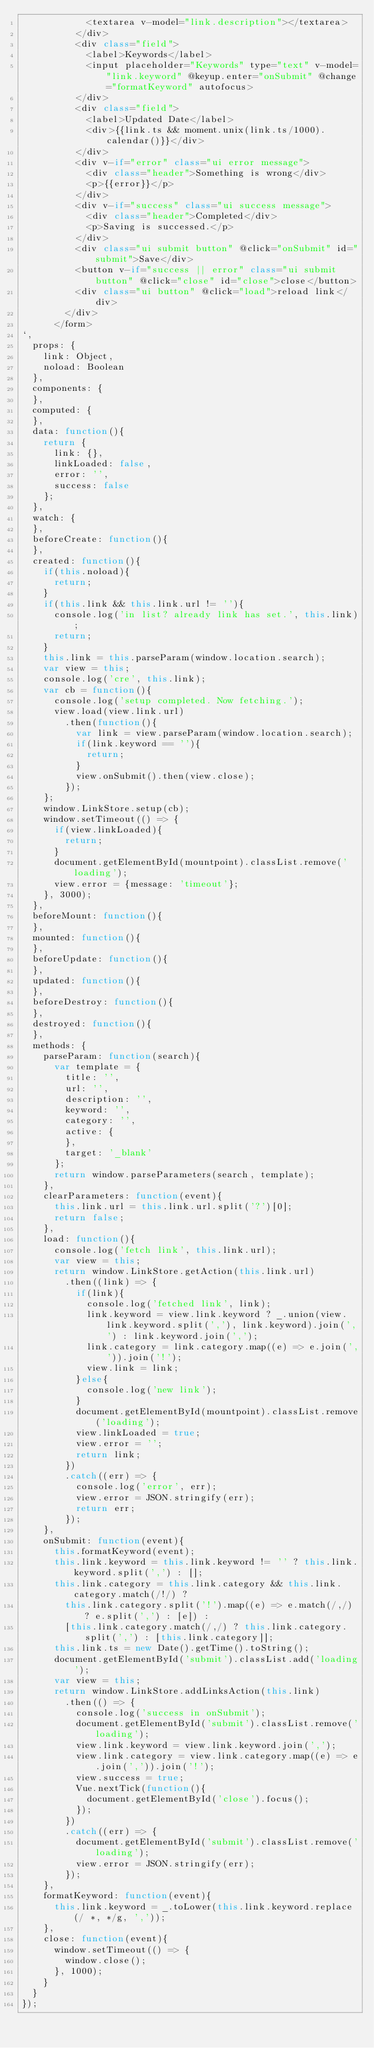<code> <loc_0><loc_0><loc_500><loc_500><_JavaScript_>            <textarea v-model="link.description"></textarea>
          </div>
          <div class="field">
            <label>Keywords</label>
            <input placeholder="Keywords" type="text" v-model="link.keyword" @keyup.enter="onSubmit" @change="formatKeyword" autofocus>
          </div>
          <div class="field">
            <label>Updated Date</label>
            <div>{{link.ts && moment.unix(link.ts/1000).calendar()}}</div>
          </div>
          <div v-if="error" class="ui error message">
            <div class="header">Something is wrong</div>
            <p>{{error}}</p>
          </div>
          <div v-if="success" class="ui success message">
            <div class="header">Completed</div>
            <p>Saving is successed.</p>
          </div>
          <div class="ui submit button" @click="onSubmit" id="submit">Save</div>
          <button v-if="success || error" class="ui submit button" @click="close" id="close">close</button>
          <div class="ui button" @click="load">reload link</div>
        </div>
      </form>
`,
  props: {
    link: Object,
    noload: Boolean
  },
  components: {
  },
  computed: {
  },
  data: function(){
    return {
      link: {},
      linkLoaded: false,
      error: '',
      success: false
    };
  },
  watch: {
  },
  beforeCreate: function(){
  },
  created: function(){
    if(this.noload){
      return;
    }
    if(this.link && this.link.url != ''){
      console.log('in list? already link has set.', this.link);
      return;
    }
    this.link = this.parseParam(window.location.search);
    var view = this;
    console.log('cre', this.link);
    var cb = function(){
      console.log('setup completed. Now fetching.');
      view.load(view.link.url)
        .then(function(){
          var link = view.parseParam(window.location.search);
          if(link.keyword == ''){
            return;
          }
          view.onSubmit().then(view.close);
        });
    };
    window.LinkStore.setup(cb);
    window.setTimeout(() => {
      if(view.linkLoaded){
        return;
      }
      document.getElementById(mountpoint).classList.remove('loading');
      view.error = {message: 'timeout'};
    }, 3000);
  },
  beforeMount: function(){
  },
  mounted: function(){
  },
  beforeUpdate: function(){
  },
  updated: function(){
  },
  beforeDestroy: function(){
  },
  destroyed: function(){
  },
  methods: {
    parseParam: function(search){
      var template = {
        title: '',
        url: '',
        description: '',
        keyword: '',
        category: '',
        active: {
        },
        target: '_blank'
      };
      return window.parseParameters(search, template);
    },
    clearParameters: function(event){
      this.link.url = this.link.url.split('?')[0];
      return false;
    },
    load: function(){
      console.log('fetch link', this.link.url);
      var view = this;
      return window.LinkStore.getAction(this.link.url)
        .then((link) => {
          if(link){
            console.log('fetched link', link);
            link.keyword = view.link.keyword ? _.union(view.link.keyword.split(','), link.keyword).join(',') : link.keyword.join(',');
            link.category = link.category.map((e) => e.join(',')).join('!');
            view.link = link;
          }else{
            console.log('new link');
          }
          document.getElementById(mountpoint).classList.remove('loading');
          view.linkLoaded = true;
          view.error = '';
          return link;
        })
        .catch((err) => {
          console.log('error', err);
          view.error = JSON.stringify(err);
          return err;
        });
    },
    onSubmit: function(event){
      this.formatKeyword(event);
      this.link.keyword = this.link.keyword != '' ? this.link.keyword.split(',') : [];
      this.link.category = this.link.category && this.link.category.match(/!/) ?
        this.link.category.split('!').map((e) => e.match(/,/) ? e.split(',') : [e]) :
        [this.link.category.match(/,/) ? this.link.category.split(',') : [this.link.category]];
      this.link.ts = new Date().getTime().toString();
      document.getElementById('submit').classList.add('loading');
      var view = this;
      return window.LinkStore.addLinksAction(this.link)
        .then(() => {
          console.log('success in onSubmit');
          document.getElementById('submit').classList.remove('loading');
          view.link.keyword = view.link.keyword.join(',');
          view.link.category = view.link.category.map((e) => e.join(',')).join('!');
          view.success = true;
          Vue.nextTick(function(){
            document.getElementById('close').focus();
          });
        })
        .catch((err) => {
          document.getElementById('submit').classList.remove('loading');
          view.error = JSON.stringify(err);
        });
    },
    formatKeyword: function(event){
      this.link.keyword = _.toLower(this.link.keyword.replace(/ *, */g, ','));
    },
    close: function(event){
      window.setTimeout(() => {
        window.close();
      }, 1000);
    }
  }
});
</code> 